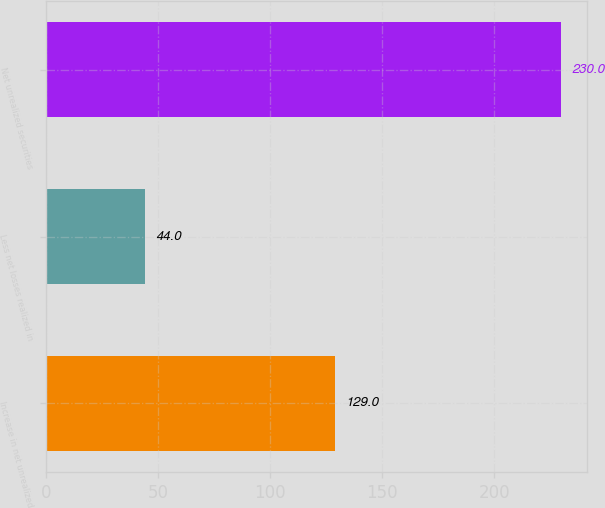Convert chart. <chart><loc_0><loc_0><loc_500><loc_500><bar_chart><fcel>Increase in net unrealized<fcel>Less net losses realized in<fcel>Net unrealized securities<nl><fcel>129<fcel>44<fcel>230<nl></chart> 